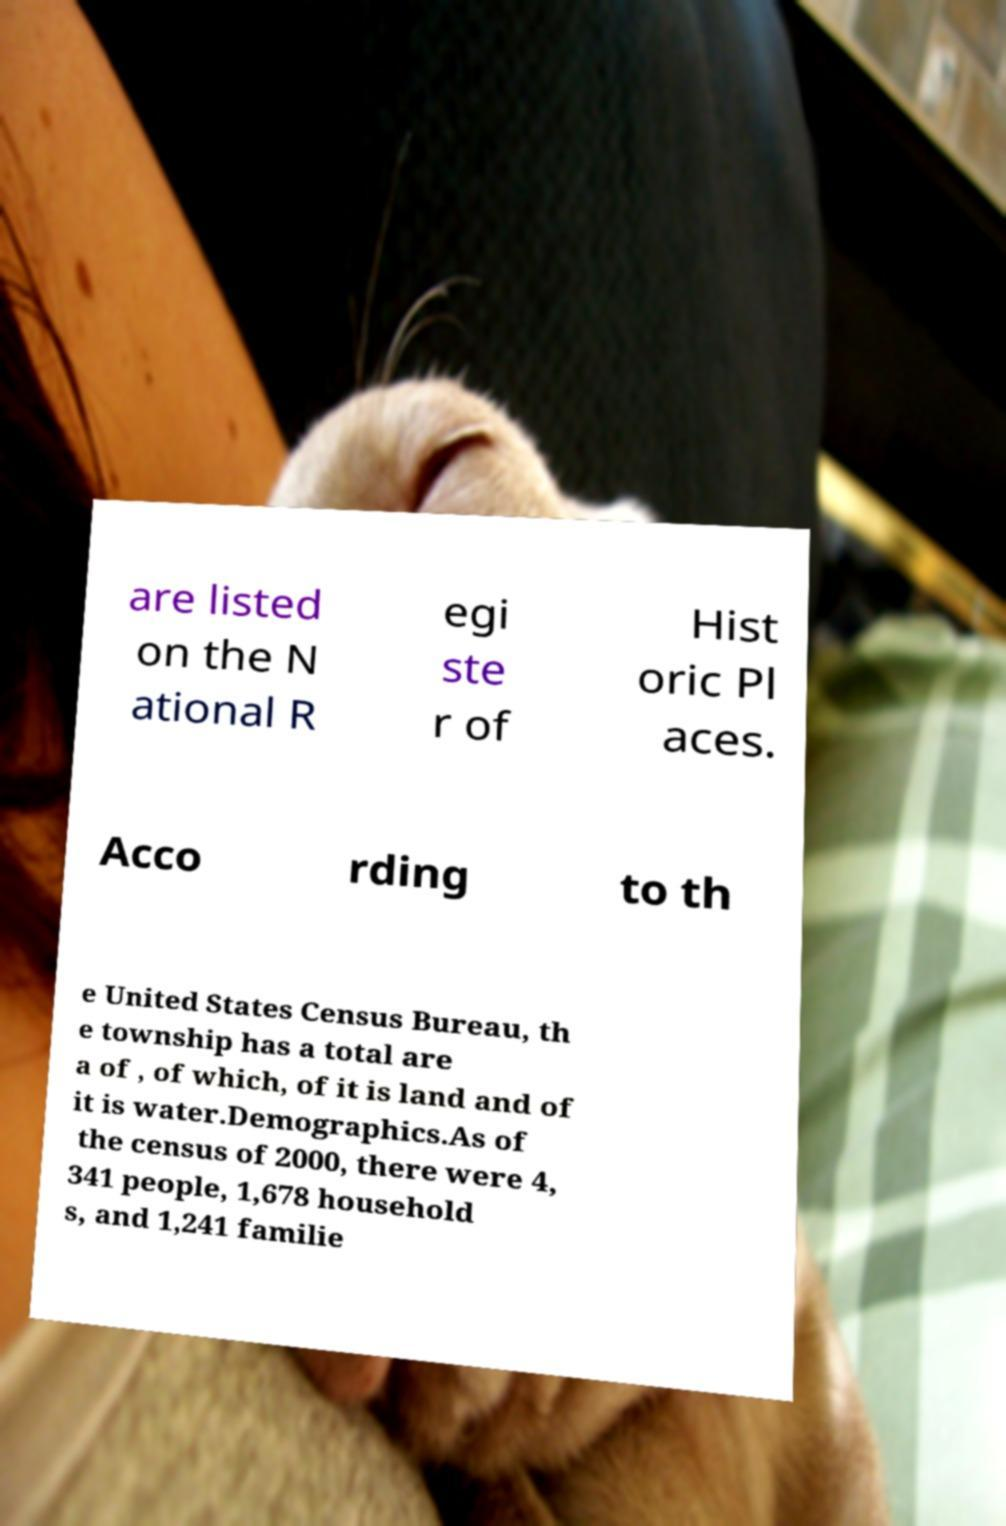Could you assist in decoding the text presented in this image and type it out clearly? are listed on the N ational R egi ste r of Hist oric Pl aces. Acco rding to th e United States Census Bureau, th e township has a total are a of , of which, of it is land and of it is water.Demographics.As of the census of 2000, there were 4, 341 people, 1,678 household s, and 1,241 familie 